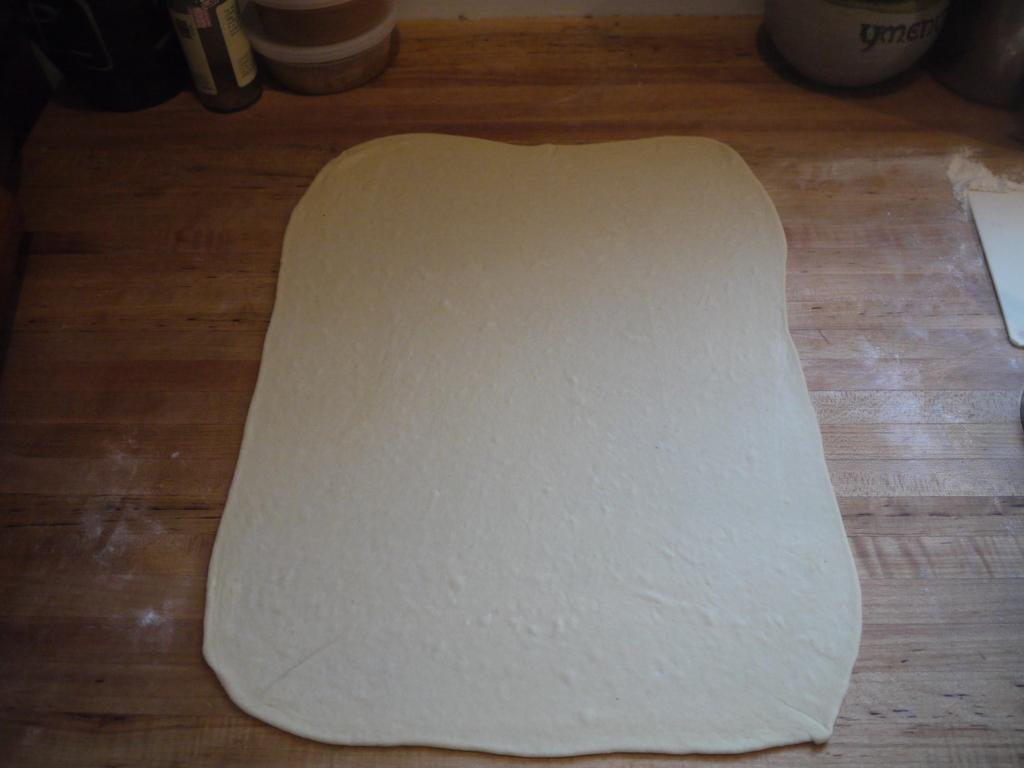What type of objects are on the wooden surface in the image? There are flour objects on a wooden surface in the image. Can you describe the objects visible at the top of the image? Unfortunately, the provided facts do not mention any objects visible at the top of the image. What type of marble is being used as a lunchroom table in the image? There is no marble or lunchroom table present in the image. 